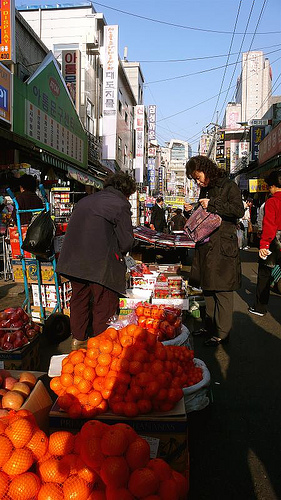Please provide a short description for this region: [0.41, 0.33, 0.51, 0.39]. This segment shows the hair of a person, short and possibly graying, providing a sense of the person's age and style. 